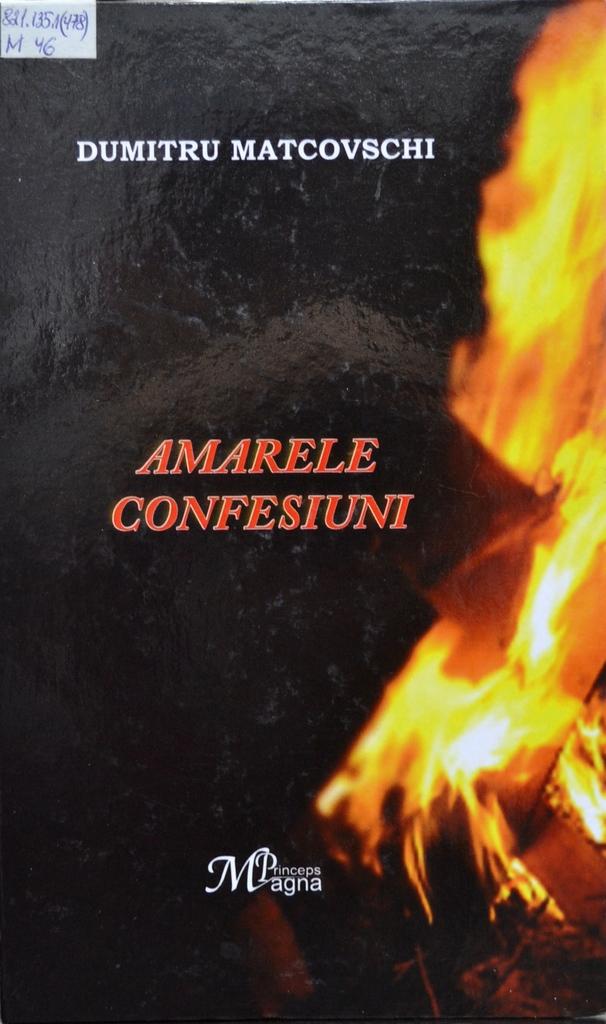Who is the author of this book?
Ensure brevity in your answer.  Dumitru matcovschi. Who is the author?
Provide a short and direct response. Dumitru matcovschi. 